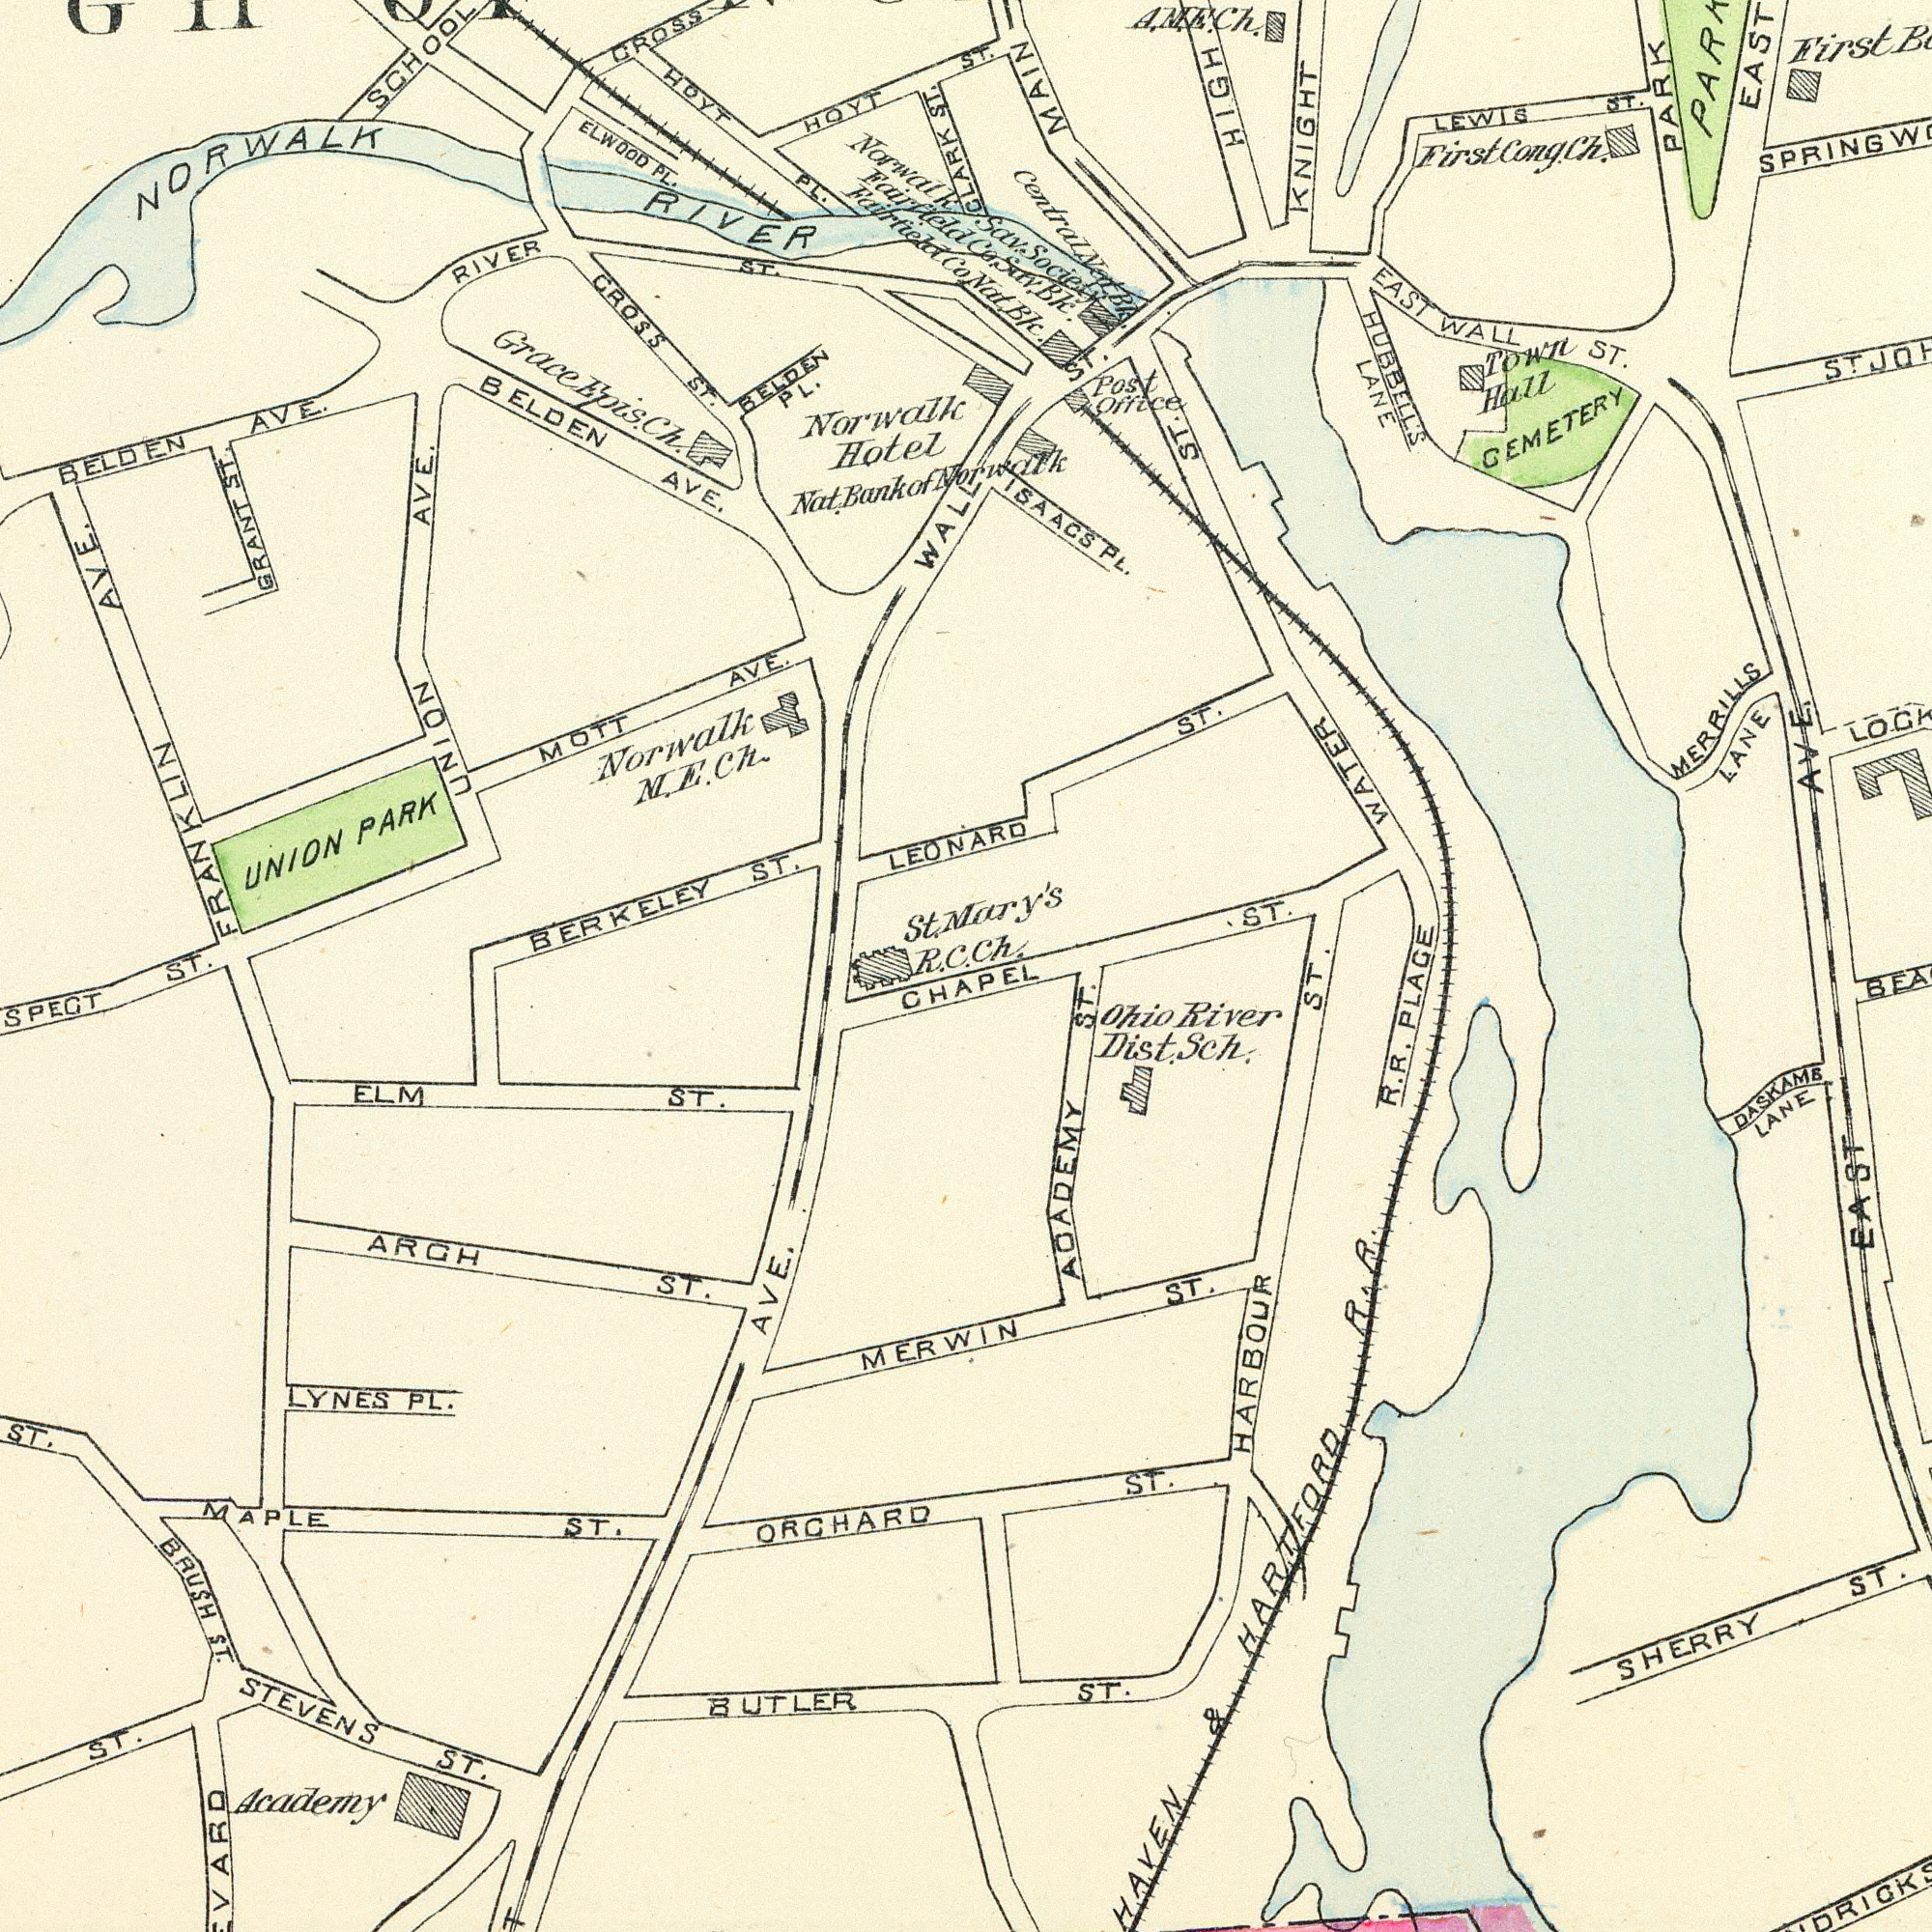What text appears in the top-left area of the image? Norwalk Hotel BELDEN AVE. GROSS ST. HOYT RIVER ST. Norwalk M. E. Ch. BERKELEY ST. BELDEN AVE. UNION AVE. MOTT AVE. CROSS UNION PARK Nat. Bank of HOYT PL. SCHOOL NORWALK RIVER ELWOOD PL. BELDEN PL. WALE ST. GRANT ST. St. R. C. FRANKLIN AVE. Norwalk Grace Epis Ch. Fairfield Fairfield Co. What text is visible in the lower-left corner? Academy STEVENS ST. ORCHARD LYNES PL. ARCH ST. AVE. ST. MAPLE ST. ELM ST. MERWIN ST. BUTLER BRUSH ST. ST. What text can you see in the top-right section? ST. Norwalk ST. LEONARD ST. CLARK Mary's Ch. Sav. Society Co. Sav. Bk. EAST KNIGHT EAST WALL ST. CEMETERY MERRILLS LANE Post Office HUBBELL'S LANE Town Hall AVE. ST. HIGH ISAACS PL. PARK PARK LEWIS ST. First WATER ST. A. M. E. Ch. MAIN Nat. Bk. Central Nat. Bk. First Cong. Ch. What text can you see in the bottom-right section? EAST CHAPEL ST. ST. ST. ACADEMY ST. R. R. PLACE HAVEN & HARTFORD R. R. SHERRY ST. Ohio River Dist. Sch. HARBOUR ST DASKAMB LANE 